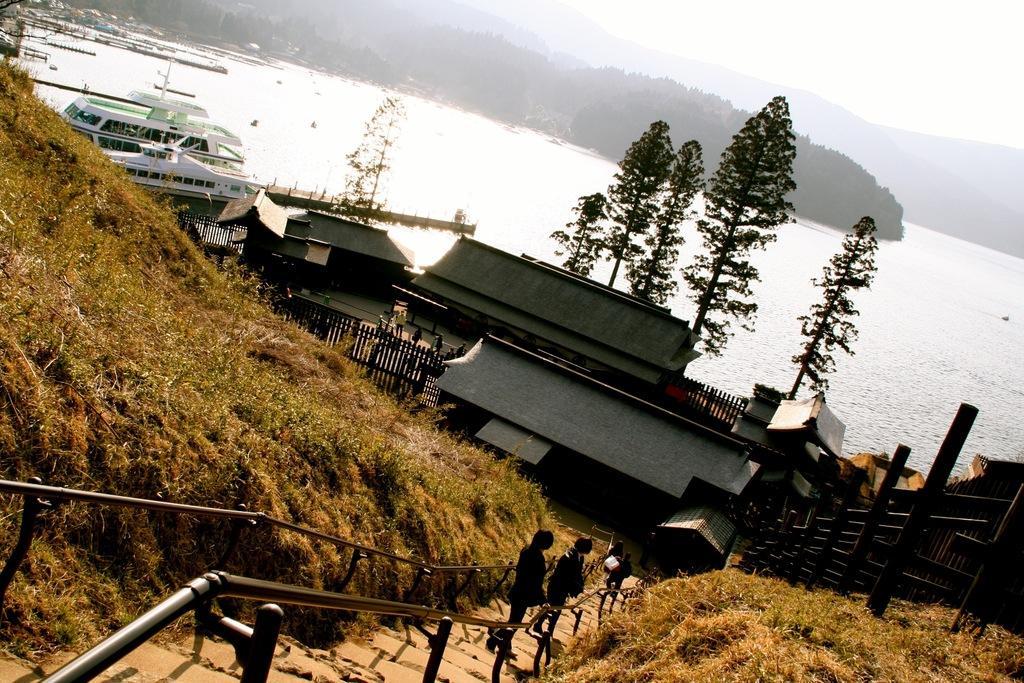How would you summarize this image in a sentence or two? We can see people, steps, railing, grass, sheds, fence and trees. We can see ships and water. In the background we can see trees, hills and sky. 